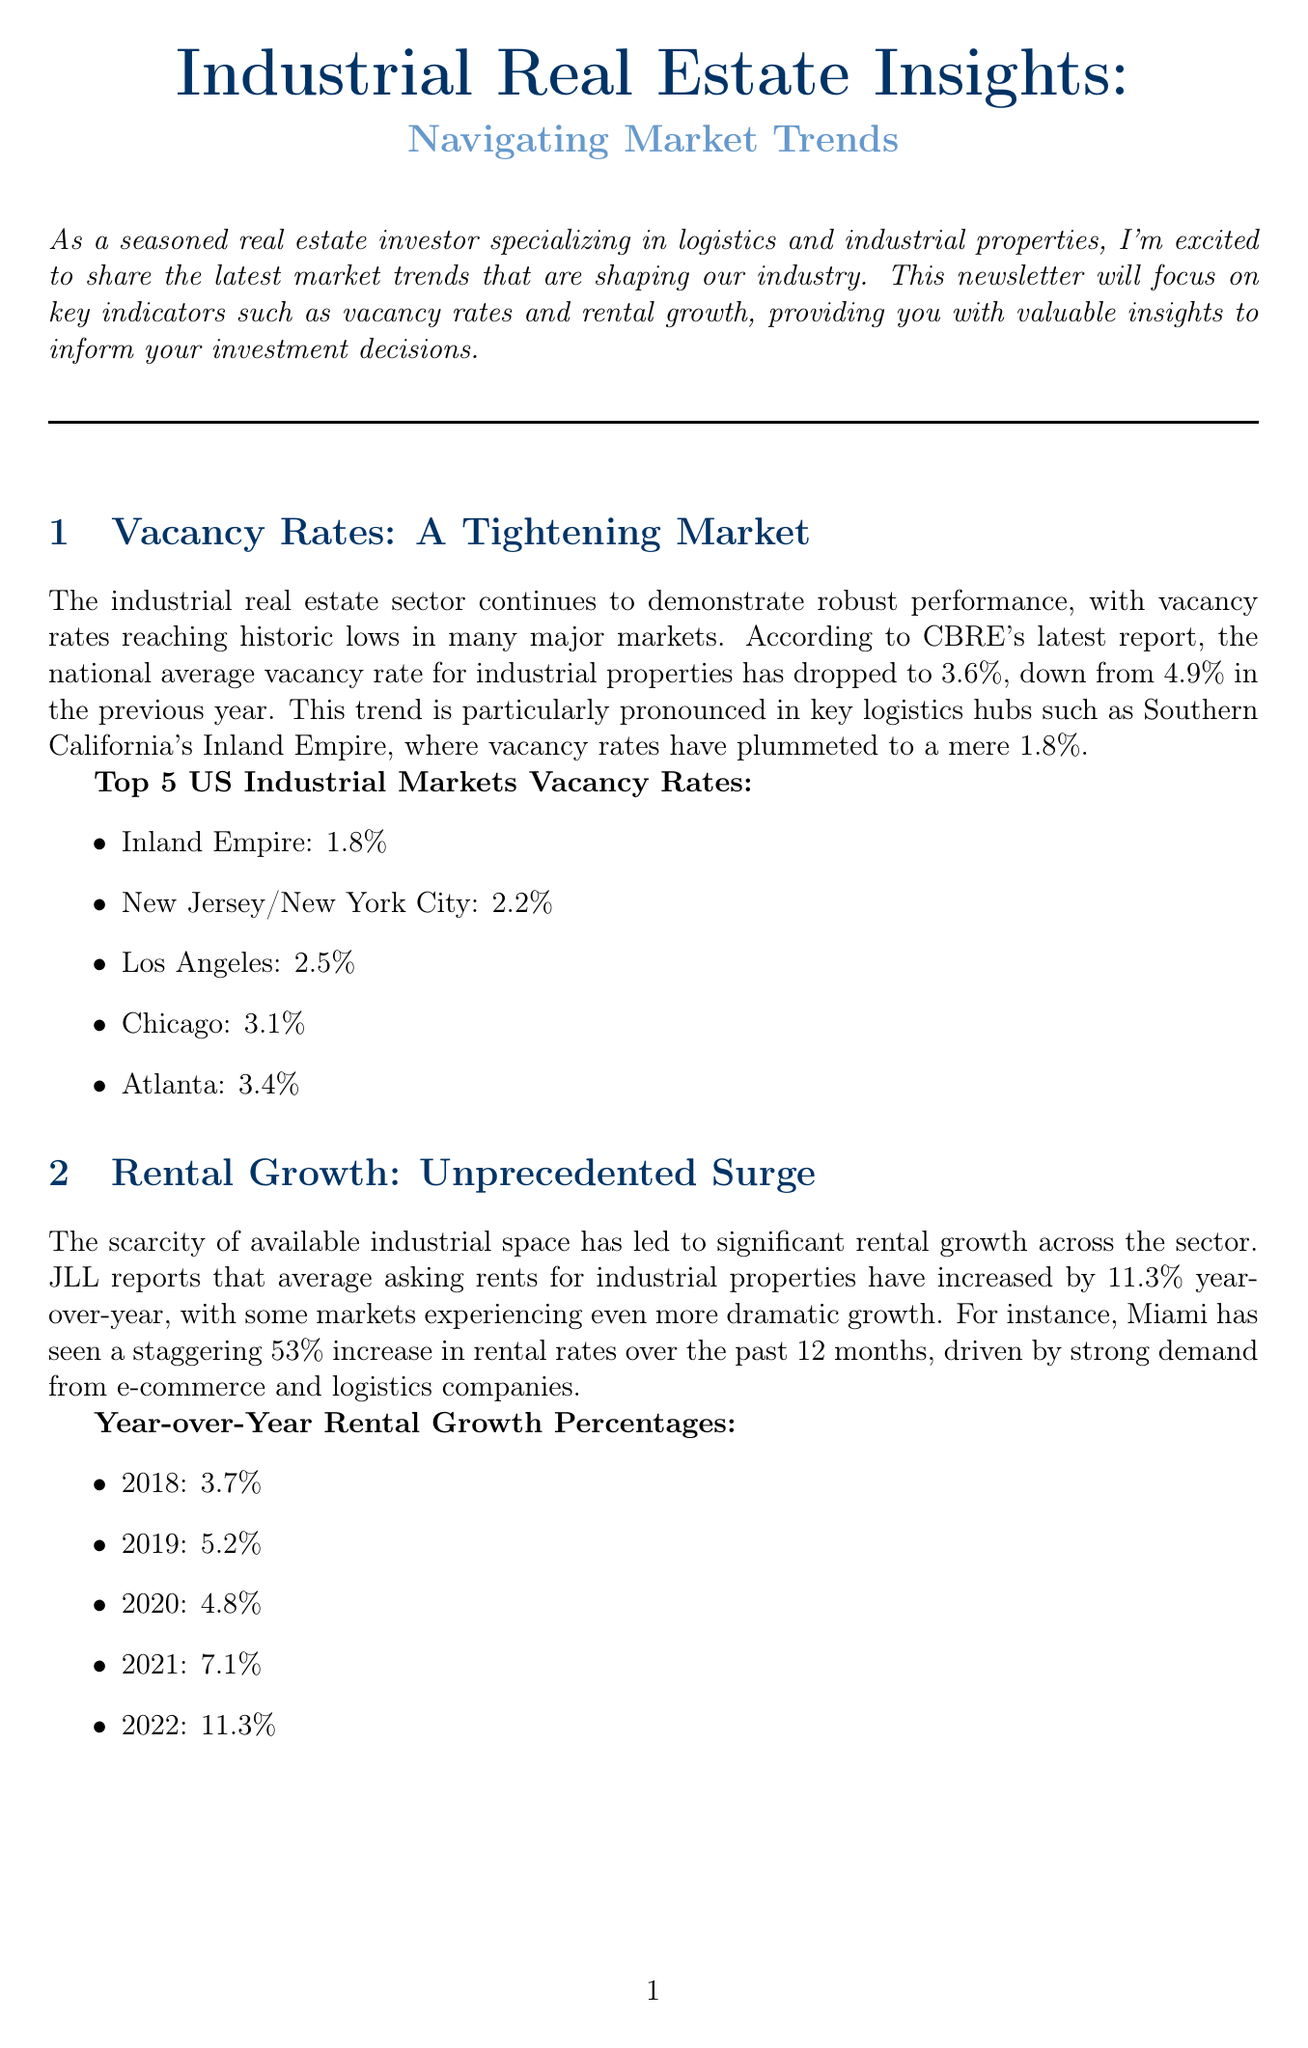What is the national average vacancy rate for industrial properties? The national average vacancy rate for industrial properties has decreased to 3.6% from 4.9% the previous year.
Answer: 3.6% What was the year-over-year increase in average asking rents for industrial properties? The newsletter mentions an increase of 11.3% year-over-year in average asking rents across the industrial sector.
Answer: 11.3% Which market has the lowest vacancy rate? According to the document, the Inland Empire has the lowest vacancy rate at 1.8%.
Answer: Inland Empire What is the percentage increase in rental rates in Miami? The newsletter points out that Miami experienced a 53% increase in rental rates over the past 12 months.
Answer: 53% What is the total square footage of new industrial space delivered in Phoenix in the past year? The document states that Phoenix has seen over 20 million square feet of new industrial space delivered in the last year.
Answer: 20 million What trend is driving demand for industrial real estate according to the newsletter? The growth in e-commerce and the focus on supply chain resilience are key factors driving the demand.
Answer: E-commerce and supply chain resilience What is a major project under construction in Phoenix? The Glendale 303 logistics park is mentioned as a major project in construction in Phoenix.
Answer: Glendale 303 logistics park What is the focus of the next newsletter? The next newsletter will cover emerging trends in sustainable industrial development and automation's impact on warehouse design.
Answer: Sustainable industrial development and automation 